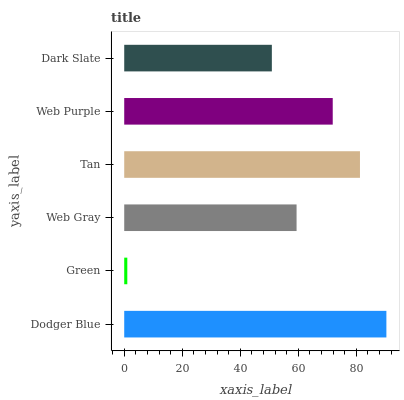Is Green the minimum?
Answer yes or no. Yes. Is Dodger Blue the maximum?
Answer yes or no. Yes. Is Web Gray the minimum?
Answer yes or no. No. Is Web Gray the maximum?
Answer yes or no. No. Is Web Gray greater than Green?
Answer yes or no. Yes. Is Green less than Web Gray?
Answer yes or no. Yes. Is Green greater than Web Gray?
Answer yes or no. No. Is Web Gray less than Green?
Answer yes or no. No. Is Web Purple the high median?
Answer yes or no. Yes. Is Web Gray the low median?
Answer yes or no. Yes. Is Web Gray the high median?
Answer yes or no. No. Is Web Purple the low median?
Answer yes or no. No. 